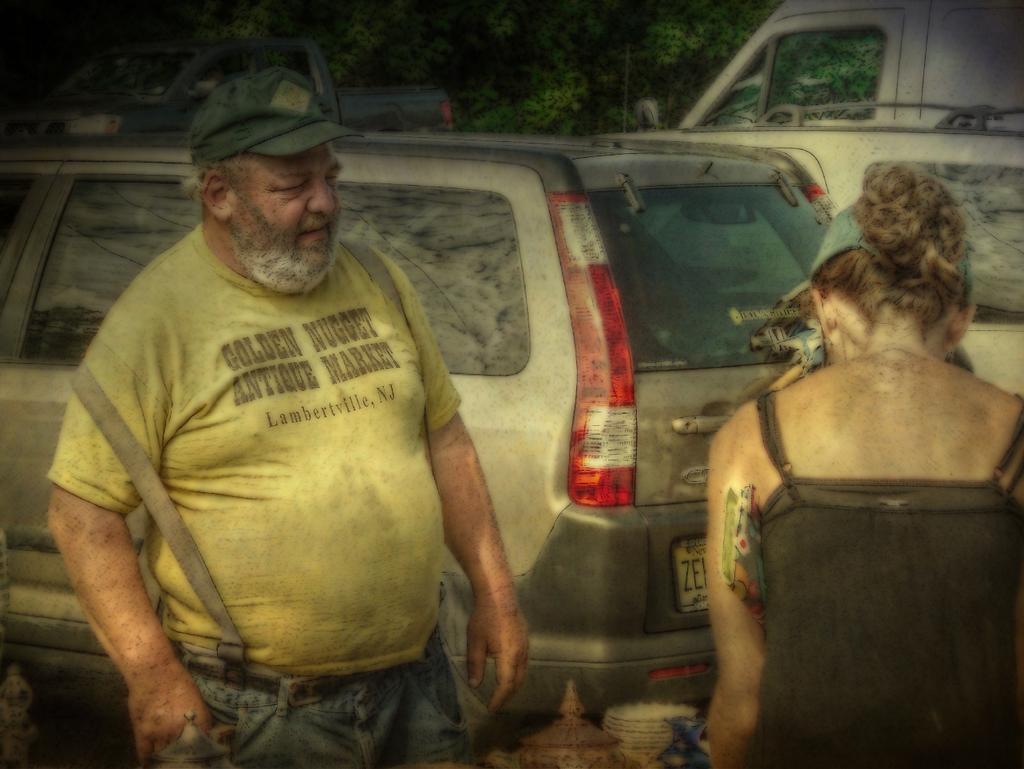How would you summarize this image in a sentence or two? There is a person in a shirt standing. On the right side, there is a woman in black color t-shirt standing in front of a table on which, there are plates and other objects. In the background, there are vehicles and trees. 